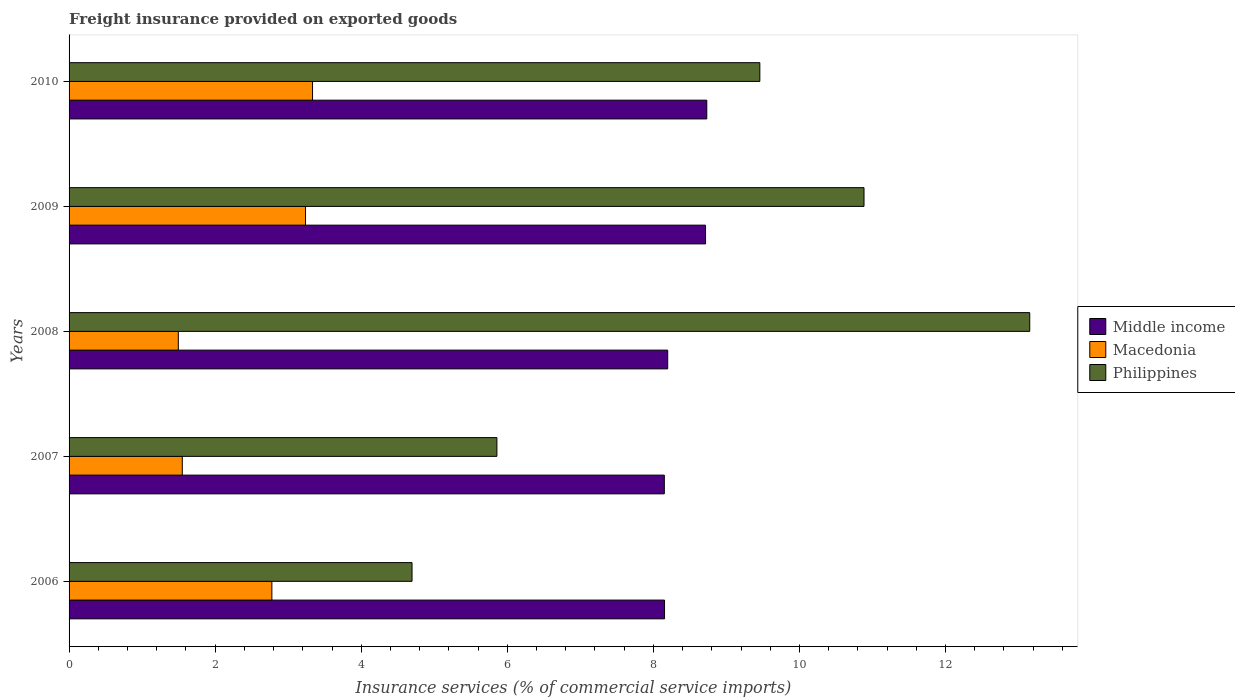How many different coloured bars are there?
Keep it short and to the point. 3. Are the number of bars on each tick of the Y-axis equal?
Offer a terse response. Yes. What is the label of the 5th group of bars from the top?
Provide a short and direct response. 2006. In how many cases, is the number of bars for a given year not equal to the number of legend labels?
Provide a succinct answer. 0. What is the freight insurance provided on exported goods in Philippines in 2008?
Give a very brief answer. 13.15. Across all years, what is the maximum freight insurance provided on exported goods in Philippines?
Make the answer very short. 13.15. Across all years, what is the minimum freight insurance provided on exported goods in Middle income?
Provide a succinct answer. 8.15. In which year was the freight insurance provided on exported goods in Middle income maximum?
Offer a terse response. 2010. In which year was the freight insurance provided on exported goods in Macedonia minimum?
Offer a terse response. 2008. What is the total freight insurance provided on exported goods in Macedonia in the graph?
Offer a terse response. 12.39. What is the difference between the freight insurance provided on exported goods in Middle income in 2008 and that in 2009?
Your answer should be compact. -0.52. What is the difference between the freight insurance provided on exported goods in Philippines in 2006 and the freight insurance provided on exported goods in Middle income in 2009?
Keep it short and to the point. -4.02. What is the average freight insurance provided on exported goods in Middle income per year?
Give a very brief answer. 8.39. In the year 2010, what is the difference between the freight insurance provided on exported goods in Philippines and freight insurance provided on exported goods in Middle income?
Your answer should be compact. 0.73. What is the ratio of the freight insurance provided on exported goods in Philippines in 2006 to that in 2008?
Offer a terse response. 0.36. Is the difference between the freight insurance provided on exported goods in Philippines in 2008 and 2010 greater than the difference between the freight insurance provided on exported goods in Middle income in 2008 and 2010?
Ensure brevity in your answer.  Yes. What is the difference between the highest and the second highest freight insurance provided on exported goods in Philippines?
Offer a terse response. 2.27. What is the difference between the highest and the lowest freight insurance provided on exported goods in Philippines?
Make the answer very short. 8.46. In how many years, is the freight insurance provided on exported goods in Macedonia greater than the average freight insurance provided on exported goods in Macedonia taken over all years?
Your answer should be very brief. 3. Is the sum of the freight insurance provided on exported goods in Macedonia in 2006 and 2010 greater than the maximum freight insurance provided on exported goods in Middle income across all years?
Provide a short and direct response. No. What does the 1st bar from the top in 2006 represents?
Offer a terse response. Philippines. What does the 2nd bar from the bottom in 2008 represents?
Your answer should be very brief. Macedonia. Is it the case that in every year, the sum of the freight insurance provided on exported goods in Middle income and freight insurance provided on exported goods in Macedonia is greater than the freight insurance provided on exported goods in Philippines?
Ensure brevity in your answer.  No. Are all the bars in the graph horizontal?
Provide a short and direct response. Yes. How many years are there in the graph?
Your response must be concise. 5. Does the graph contain grids?
Offer a very short reply. No. Where does the legend appear in the graph?
Keep it short and to the point. Center right. How many legend labels are there?
Ensure brevity in your answer.  3. How are the legend labels stacked?
Provide a short and direct response. Vertical. What is the title of the graph?
Provide a short and direct response. Freight insurance provided on exported goods. What is the label or title of the X-axis?
Offer a very short reply. Insurance services (% of commercial service imports). What is the Insurance services (% of commercial service imports) of Middle income in 2006?
Offer a terse response. 8.15. What is the Insurance services (% of commercial service imports) of Macedonia in 2006?
Ensure brevity in your answer.  2.78. What is the Insurance services (% of commercial service imports) of Philippines in 2006?
Your response must be concise. 4.7. What is the Insurance services (% of commercial service imports) in Middle income in 2007?
Ensure brevity in your answer.  8.15. What is the Insurance services (% of commercial service imports) of Macedonia in 2007?
Provide a succinct answer. 1.55. What is the Insurance services (% of commercial service imports) of Philippines in 2007?
Offer a terse response. 5.86. What is the Insurance services (% of commercial service imports) of Middle income in 2008?
Offer a very short reply. 8.2. What is the Insurance services (% of commercial service imports) of Macedonia in 2008?
Keep it short and to the point. 1.5. What is the Insurance services (% of commercial service imports) of Philippines in 2008?
Your response must be concise. 13.15. What is the Insurance services (% of commercial service imports) of Middle income in 2009?
Ensure brevity in your answer.  8.71. What is the Insurance services (% of commercial service imports) in Macedonia in 2009?
Your response must be concise. 3.24. What is the Insurance services (% of commercial service imports) of Philippines in 2009?
Your answer should be very brief. 10.88. What is the Insurance services (% of commercial service imports) of Middle income in 2010?
Make the answer very short. 8.73. What is the Insurance services (% of commercial service imports) in Macedonia in 2010?
Your answer should be compact. 3.33. What is the Insurance services (% of commercial service imports) in Philippines in 2010?
Offer a very short reply. 9.46. Across all years, what is the maximum Insurance services (% of commercial service imports) of Middle income?
Offer a very short reply. 8.73. Across all years, what is the maximum Insurance services (% of commercial service imports) of Macedonia?
Provide a succinct answer. 3.33. Across all years, what is the maximum Insurance services (% of commercial service imports) in Philippines?
Give a very brief answer. 13.15. Across all years, what is the minimum Insurance services (% of commercial service imports) in Middle income?
Ensure brevity in your answer.  8.15. Across all years, what is the minimum Insurance services (% of commercial service imports) of Macedonia?
Provide a succinct answer. 1.5. Across all years, what is the minimum Insurance services (% of commercial service imports) of Philippines?
Make the answer very short. 4.7. What is the total Insurance services (% of commercial service imports) in Middle income in the graph?
Offer a very short reply. 41.94. What is the total Insurance services (% of commercial service imports) of Macedonia in the graph?
Your response must be concise. 12.39. What is the total Insurance services (% of commercial service imports) of Philippines in the graph?
Provide a succinct answer. 44.05. What is the difference between the Insurance services (% of commercial service imports) of Middle income in 2006 and that in 2007?
Your response must be concise. 0. What is the difference between the Insurance services (% of commercial service imports) in Macedonia in 2006 and that in 2007?
Your answer should be very brief. 1.23. What is the difference between the Insurance services (% of commercial service imports) of Philippines in 2006 and that in 2007?
Offer a terse response. -1.16. What is the difference between the Insurance services (% of commercial service imports) in Middle income in 2006 and that in 2008?
Keep it short and to the point. -0.04. What is the difference between the Insurance services (% of commercial service imports) in Macedonia in 2006 and that in 2008?
Provide a succinct answer. 1.28. What is the difference between the Insurance services (% of commercial service imports) in Philippines in 2006 and that in 2008?
Your response must be concise. -8.46. What is the difference between the Insurance services (% of commercial service imports) of Middle income in 2006 and that in 2009?
Provide a succinct answer. -0.56. What is the difference between the Insurance services (% of commercial service imports) in Macedonia in 2006 and that in 2009?
Your answer should be very brief. -0.46. What is the difference between the Insurance services (% of commercial service imports) of Philippines in 2006 and that in 2009?
Your answer should be compact. -6.19. What is the difference between the Insurance services (% of commercial service imports) of Middle income in 2006 and that in 2010?
Give a very brief answer. -0.58. What is the difference between the Insurance services (% of commercial service imports) in Macedonia in 2006 and that in 2010?
Provide a short and direct response. -0.56. What is the difference between the Insurance services (% of commercial service imports) of Philippines in 2006 and that in 2010?
Keep it short and to the point. -4.76. What is the difference between the Insurance services (% of commercial service imports) in Middle income in 2007 and that in 2008?
Your response must be concise. -0.05. What is the difference between the Insurance services (% of commercial service imports) of Macedonia in 2007 and that in 2008?
Give a very brief answer. 0.05. What is the difference between the Insurance services (% of commercial service imports) of Philippines in 2007 and that in 2008?
Your answer should be very brief. -7.3. What is the difference between the Insurance services (% of commercial service imports) of Middle income in 2007 and that in 2009?
Ensure brevity in your answer.  -0.56. What is the difference between the Insurance services (% of commercial service imports) of Macedonia in 2007 and that in 2009?
Provide a short and direct response. -1.69. What is the difference between the Insurance services (% of commercial service imports) in Philippines in 2007 and that in 2009?
Provide a succinct answer. -5.03. What is the difference between the Insurance services (% of commercial service imports) in Middle income in 2007 and that in 2010?
Provide a succinct answer. -0.58. What is the difference between the Insurance services (% of commercial service imports) in Macedonia in 2007 and that in 2010?
Keep it short and to the point. -1.78. What is the difference between the Insurance services (% of commercial service imports) of Philippines in 2007 and that in 2010?
Offer a terse response. -3.6. What is the difference between the Insurance services (% of commercial service imports) in Middle income in 2008 and that in 2009?
Your response must be concise. -0.52. What is the difference between the Insurance services (% of commercial service imports) in Macedonia in 2008 and that in 2009?
Your answer should be compact. -1.74. What is the difference between the Insurance services (% of commercial service imports) in Philippines in 2008 and that in 2009?
Provide a short and direct response. 2.27. What is the difference between the Insurance services (% of commercial service imports) in Middle income in 2008 and that in 2010?
Provide a succinct answer. -0.54. What is the difference between the Insurance services (% of commercial service imports) of Macedonia in 2008 and that in 2010?
Provide a succinct answer. -1.84. What is the difference between the Insurance services (% of commercial service imports) of Philippines in 2008 and that in 2010?
Make the answer very short. 3.7. What is the difference between the Insurance services (% of commercial service imports) in Middle income in 2009 and that in 2010?
Ensure brevity in your answer.  -0.02. What is the difference between the Insurance services (% of commercial service imports) in Macedonia in 2009 and that in 2010?
Ensure brevity in your answer.  -0.1. What is the difference between the Insurance services (% of commercial service imports) in Philippines in 2009 and that in 2010?
Keep it short and to the point. 1.43. What is the difference between the Insurance services (% of commercial service imports) in Middle income in 2006 and the Insurance services (% of commercial service imports) in Macedonia in 2007?
Provide a short and direct response. 6.6. What is the difference between the Insurance services (% of commercial service imports) of Middle income in 2006 and the Insurance services (% of commercial service imports) of Philippines in 2007?
Your answer should be compact. 2.29. What is the difference between the Insurance services (% of commercial service imports) in Macedonia in 2006 and the Insurance services (% of commercial service imports) in Philippines in 2007?
Ensure brevity in your answer.  -3.08. What is the difference between the Insurance services (% of commercial service imports) in Middle income in 2006 and the Insurance services (% of commercial service imports) in Macedonia in 2008?
Provide a succinct answer. 6.66. What is the difference between the Insurance services (% of commercial service imports) of Middle income in 2006 and the Insurance services (% of commercial service imports) of Philippines in 2008?
Keep it short and to the point. -5. What is the difference between the Insurance services (% of commercial service imports) in Macedonia in 2006 and the Insurance services (% of commercial service imports) in Philippines in 2008?
Make the answer very short. -10.38. What is the difference between the Insurance services (% of commercial service imports) in Middle income in 2006 and the Insurance services (% of commercial service imports) in Macedonia in 2009?
Offer a very short reply. 4.92. What is the difference between the Insurance services (% of commercial service imports) in Middle income in 2006 and the Insurance services (% of commercial service imports) in Philippines in 2009?
Make the answer very short. -2.73. What is the difference between the Insurance services (% of commercial service imports) in Macedonia in 2006 and the Insurance services (% of commercial service imports) in Philippines in 2009?
Your answer should be compact. -8.11. What is the difference between the Insurance services (% of commercial service imports) in Middle income in 2006 and the Insurance services (% of commercial service imports) in Macedonia in 2010?
Provide a succinct answer. 4.82. What is the difference between the Insurance services (% of commercial service imports) of Middle income in 2006 and the Insurance services (% of commercial service imports) of Philippines in 2010?
Give a very brief answer. -1.31. What is the difference between the Insurance services (% of commercial service imports) of Macedonia in 2006 and the Insurance services (% of commercial service imports) of Philippines in 2010?
Provide a short and direct response. -6.68. What is the difference between the Insurance services (% of commercial service imports) in Middle income in 2007 and the Insurance services (% of commercial service imports) in Macedonia in 2008?
Your answer should be very brief. 6.65. What is the difference between the Insurance services (% of commercial service imports) of Middle income in 2007 and the Insurance services (% of commercial service imports) of Philippines in 2008?
Your answer should be compact. -5. What is the difference between the Insurance services (% of commercial service imports) in Macedonia in 2007 and the Insurance services (% of commercial service imports) in Philippines in 2008?
Keep it short and to the point. -11.6. What is the difference between the Insurance services (% of commercial service imports) of Middle income in 2007 and the Insurance services (% of commercial service imports) of Macedonia in 2009?
Provide a short and direct response. 4.91. What is the difference between the Insurance services (% of commercial service imports) in Middle income in 2007 and the Insurance services (% of commercial service imports) in Philippines in 2009?
Provide a succinct answer. -2.73. What is the difference between the Insurance services (% of commercial service imports) of Macedonia in 2007 and the Insurance services (% of commercial service imports) of Philippines in 2009?
Provide a short and direct response. -9.33. What is the difference between the Insurance services (% of commercial service imports) in Middle income in 2007 and the Insurance services (% of commercial service imports) in Macedonia in 2010?
Provide a short and direct response. 4.82. What is the difference between the Insurance services (% of commercial service imports) of Middle income in 2007 and the Insurance services (% of commercial service imports) of Philippines in 2010?
Ensure brevity in your answer.  -1.31. What is the difference between the Insurance services (% of commercial service imports) of Macedonia in 2007 and the Insurance services (% of commercial service imports) of Philippines in 2010?
Keep it short and to the point. -7.91. What is the difference between the Insurance services (% of commercial service imports) of Middle income in 2008 and the Insurance services (% of commercial service imports) of Macedonia in 2009?
Offer a terse response. 4.96. What is the difference between the Insurance services (% of commercial service imports) in Middle income in 2008 and the Insurance services (% of commercial service imports) in Philippines in 2009?
Provide a short and direct response. -2.69. What is the difference between the Insurance services (% of commercial service imports) of Macedonia in 2008 and the Insurance services (% of commercial service imports) of Philippines in 2009?
Provide a succinct answer. -9.39. What is the difference between the Insurance services (% of commercial service imports) of Middle income in 2008 and the Insurance services (% of commercial service imports) of Macedonia in 2010?
Your response must be concise. 4.86. What is the difference between the Insurance services (% of commercial service imports) in Middle income in 2008 and the Insurance services (% of commercial service imports) in Philippines in 2010?
Ensure brevity in your answer.  -1.26. What is the difference between the Insurance services (% of commercial service imports) of Macedonia in 2008 and the Insurance services (% of commercial service imports) of Philippines in 2010?
Keep it short and to the point. -7.96. What is the difference between the Insurance services (% of commercial service imports) in Middle income in 2009 and the Insurance services (% of commercial service imports) in Macedonia in 2010?
Your response must be concise. 5.38. What is the difference between the Insurance services (% of commercial service imports) in Middle income in 2009 and the Insurance services (% of commercial service imports) in Philippines in 2010?
Provide a succinct answer. -0.74. What is the difference between the Insurance services (% of commercial service imports) in Macedonia in 2009 and the Insurance services (% of commercial service imports) in Philippines in 2010?
Your answer should be very brief. -6.22. What is the average Insurance services (% of commercial service imports) in Middle income per year?
Keep it short and to the point. 8.39. What is the average Insurance services (% of commercial service imports) of Macedonia per year?
Ensure brevity in your answer.  2.48. What is the average Insurance services (% of commercial service imports) in Philippines per year?
Offer a terse response. 8.81. In the year 2006, what is the difference between the Insurance services (% of commercial service imports) in Middle income and Insurance services (% of commercial service imports) in Macedonia?
Ensure brevity in your answer.  5.38. In the year 2006, what is the difference between the Insurance services (% of commercial service imports) in Middle income and Insurance services (% of commercial service imports) in Philippines?
Keep it short and to the point. 3.46. In the year 2006, what is the difference between the Insurance services (% of commercial service imports) in Macedonia and Insurance services (% of commercial service imports) in Philippines?
Provide a succinct answer. -1.92. In the year 2007, what is the difference between the Insurance services (% of commercial service imports) of Middle income and Insurance services (% of commercial service imports) of Macedonia?
Your answer should be compact. 6.6. In the year 2007, what is the difference between the Insurance services (% of commercial service imports) of Middle income and Insurance services (% of commercial service imports) of Philippines?
Your response must be concise. 2.29. In the year 2007, what is the difference between the Insurance services (% of commercial service imports) in Macedonia and Insurance services (% of commercial service imports) in Philippines?
Give a very brief answer. -4.31. In the year 2008, what is the difference between the Insurance services (% of commercial service imports) in Middle income and Insurance services (% of commercial service imports) in Macedonia?
Provide a succinct answer. 6.7. In the year 2008, what is the difference between the Insurance services (% of commercial service imports) of Middle income and Insurance services (% of commercial service imports) of Philippines?
Offer a terse response. -4.96. In the year 2008, what is the difference between the Insurance services (% of commercial service imports) of Macedonia and Insurance services (% of commercial service imports) of Philippines?
Keep it short and to the point. -11.66. In the year 2009, what is the difference between the Insurance services (% of commercial service imports) of Middle income and Insurance services (% of commercial service imports) of Macedonia?
Your response must be concise. 5.48. In the year 2009, what is the difference between the Insurance services (% of commercial service imports) in Middle income and Insurance services (% of commercial service imports) in Philippines?
Offer a very short reply. -2.17. In the year 2009, what is the difference between the Insurance services (% of commercial service imports) of Macedonia and Insurance services (% of commercial service imports) of Philippines?
Offer a very short reply. -7.65. In the year 2010, what is the difference between the Insurance services (% of commercial service imports) in Middle income and Insurance services (% of commercial service imports) in Macedonia?
Make the answer very short. 5.4. In the year 2010, what is the difference between the Insurance services (% of commercial service imports) of Middle income and Insurance services (% of commercial service imports) of Philippines?
Provide a short and direct response. -0.73. In the year 2010, what is the difference between the Insurance services (% of commercial service imports) in Macedonia and Insurance services (% of commercial service imports) in Philippines?
Offer a very short reply. -6.12. What is the ratio of the Insurance services (% of commercial service imports) in Macedonia in 2006 to that in 2007?
Provide a succinct answer. 1.79. What is the ratio of the Insurance services (% of commercial service imports) in Philippines in 2006 to that in 2007?
Give a very brief answer. 0.8. What is the ratio of the Insurance services (% of commercial service imports) in Macedonia in 2006 to that in 2008?
Offer a very short reply. 1.86. What is the ratio of the Insurance services (% of commercial service imports) of Philippines in 2006 to that in 2008?
Ensure brevity in your answer.  0.36. What is the ratio of the Insurance services (% of commercial service imports) in Middle income in 2006 to that in 2009?
Provide a short and direct response. 0.94. What is the ratio of the Insurance services (% of commercial service imports) of Macedonia in 2006 to that in 2009?
Give a very brief answer. 0.86. What is the ratio of the Insurance services (% of commercial service imports) of Philippines in 2006 to that in 2009?
Keep it short and to the point. 0.43. What is the ratio of the Insurance services (% of commercial service imports) of Middle income in 2006 to that in 2010?
Your answer should be very brief. 0.93. What is the ratio of the Insurance services (% of commercial service imports) in Macedonia in 2006 to that in 2010?
Offer a terse response. 0.83. What is the ratio of the Insurance services (% of commercial service imports) of Philippines in 2006 to that in 2010?
Ensure brevity in your answer.  0.5. What is the ratio of the Insurance services (% of commercial service imports) in Middle income in 2007 to that in 2008?
Give a very brief answer. 0.99. What is the ratio of the Insurance services (% of commercial service imports) in Macedonia in 2007 to that in 2008?
Offer a very short reply. 1.04. What is the ratio of the Insurance services (% of commercial service imports) in Philippines in 2007 to that in 2008?
Provide a succinct answer. 0.45. What is the ratio of the Insurance services (% of commercial service imports) of Middle income in 2007 to that in 2009?
Make the answer very short. 0.94. What is the ratio of the Insurance services (% of commercial service imports) in Macedonia in 2007 to that in 2009?
Your answer should be compact. 0.48. What is the ratio of the Insurance services (% of commercial service imports) of Philippines in 2007 to that in 2009?
Your response must be concise. 0.54. What is the ratio of the Insurance services (% of commercial service imports) in Middle income in 2007 to that in 2010?
Offer a very short reply. 0.93. What is the ratio of the Insurance services (% of commercial service imports) of Macedonia in 2007 to that in 2010?
Keep it short and to the point. 0.47. What is the ratio of the Insurance services (% of commercial service imports) in Philippines in 2007 to that in 2010?
Provide a short and direct response. 0.62. What is the ratio of the Insurance services (% of commercial service imports) in Middle income in 2008 to that in 2009?
Your answer should be very brief. 0.94. What is the ratio of the Insurance services (% of commercial service imports) in Macedonia in 2008 to that in 2009?
Keep it short and to the point. 0.46. What is the ratio of the Insurance services (% of commercial service imports) of Philippines in 2008 to that in 2009?
Provide a short and direct response. 1.21. What is the ratio of the Insurance services (% of commercial service imports) in Middle income in 2008 to that in 2010?
Ensure brevity in your answer.  0.94. What is the ratio of the Insurance services (% of commercial service imports) of Macedonia in 2008 to that in 2010?
Provide a short and direct response. 0.45. What is the ratio of the Insurance services (% of commercial service imports) of Philippines in 2008 to that in 2010?
Keep it short and to the point. 1.39. What is the ratio of the Insurance services (% of commercial service imports) in Macedonia in 2009 to that in 2010?
Provide a short and direct response. 0.97. What is the ratio of the Insurance services (% of commercial service imports) in Philippines in 2009 to that in 2010?
Make the answer very short. 1.15. What is the difference between the highest and the second highest Insurance services (% of commercial service imports) of Middle income?
Keep it short and to the point. 0.02. What is the difference between the highest and the second highest Insurance services (% of commercial service imports) of Macedonia?
Your answer should be compact. 0.1. What is the difference between the highest and the second highest Insurance services (% of commercial service imports) of Philippines?
Offer a very short reply. 2.27. What is the difference between the highest and the lowest Insurance services (% of commercial service imports) in Middle income?
Keep it short and to the point. 0.58. What is the difference between the highest and the lowest Insurance services (% of commercial service imports) of Macedonia?
Offer a very short reply. 1.84. What is the difference between the highest and the lowest Insurance services (% of commercial service imports) in Philippines?
Provide a succinct answer. 8.46. 